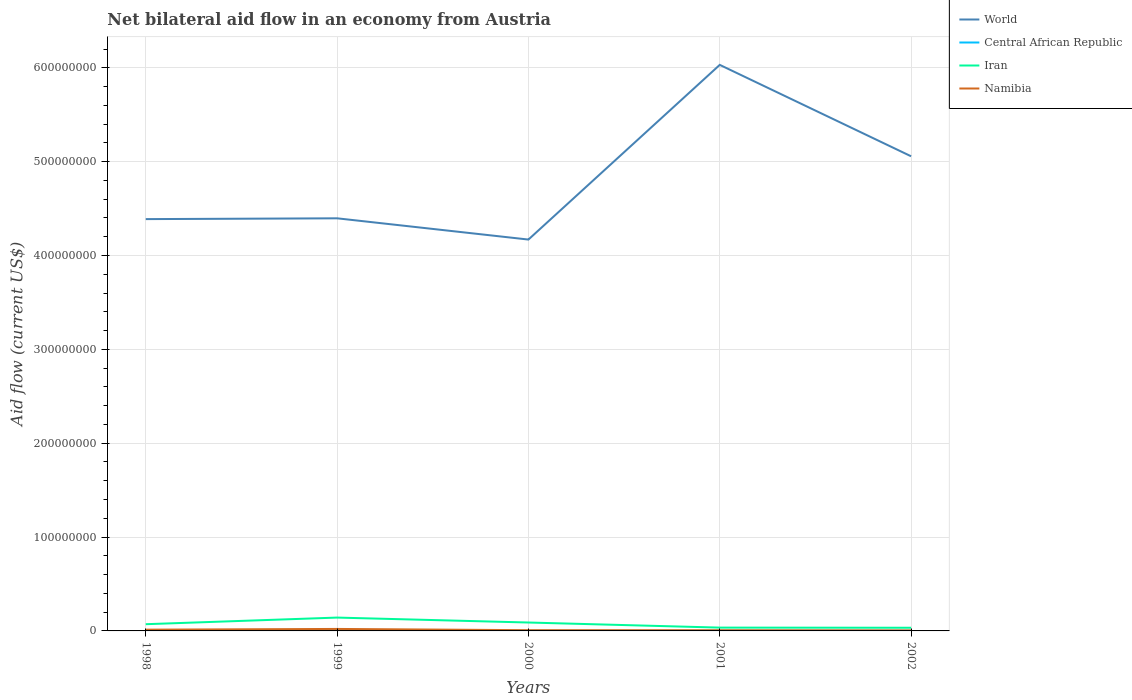Across all years, what is the maximum net bilateral aid flow in Central African Republic?
Offer a terse response. 1.40e+05. What is the total net bilateral aid flow in Namibia in the graph?
Your response must be concise. 5.50e+05. What is the difference between the highest and the second highest net bilateral aid flow in Iran?
Provide a short and direct response. 1.08e+07. What is the difference between the highest and the lowest net bilateral aid flow in Iran?
Ensure brevity in your answer.  2. How many years are there in the graph?
Your answer should be very brief. 5. What is the difference between two consecutive major ticks on the Y-axis?
Your answer should be very brief. 1.00e+08. How are the legend labels stacked?
Your response must be concise. Vertical. What is the title of the graph?
Keep it short and to the point. Net bilateral aid flow in an economy from Austria. What is the label or title of the X-axis?
Ensure brevity in your answer.  Years. What is the Aid flow (current US$) in World in 1998?
Provide a short and direct response. 4.39e+08. What is the Aid flow (current US$) in Central African Republic in 1998?
Offer a terse response. 5.50e+05. What is the Aid flow (current US$) of Iran in 1998?
Give a very brief answer. 7.16e+06. What is the Aid flow (current US$) in Namibia in 1998?
Provide a short and direct response. 1.33e+06. What is the Aid flow (current US$) in World in 1999?
Provide a short and direct response. 4.40e+08. What is the Aid flow (current US$) of Central African Republic in 1999?
Your answer should be compact. 7.40e+05. What is the Aid flow (current US$) of Iran in 1999?
Your response must be concise. 1.42e+07. What is the Aid flow (current US$) of Namibia in 1999?
Give a very brief answer. 2.11e+06. What is the Aid flow (current US$) of World in 2000?
Your answer should be very brief. 4.17e+08. What is the Aid flow (current US$) of Iran in 2000?
Your response must be concise. 8.95e+06. What is the Aid flow (current US$) of Namibia in 2000?
Offer a terse response. 7.80e+05. What is the Aid flow (current US$) in World in 2001?
Provide a succinct answer. 6.03e+08. What is the Aid flow (current US$) of Central African Republic in 2001?
Your answer should be compact. 2.00e+05. What is the Aid flow (current US$) in Iran in 2001?
Keep it short and to the point. 3.53e+06. What is the Aid flow (current US$) in Namibia in 2001?
Your response must be concise. 7.30e+05. What is the Aid flow (current US$) in World in 2002?
Offer a terse response. 5.06e+08. What is the Aid flow (current US$) of Iran in 2002?
Provide a short and direct response. 3.38e+06. What is the Aid flow (current US$) in Namibia in 2002?
Offer a terse response. 5.60e+05. Across all years, what is the maximum Aid flow (current US$) of World?
Your answer should be compact. 6.03e+08. Across all years, what is the maximum Aid flow (current US$) in Central African Republic?
Keep it short and to the point. 7.40e+05. Across all years, what is the maximum Aid flow (current US$) in Iran?
Provide a succinct answer. 1.42e+07. Across all years, what is the maximum Aid flow (current US$) of Namibia?
Keep it short and to the point. 2.11e+06. Across all years, what is the minimum Aid flow (current US$) of World?
Keep it short and to the point. 4.17e+08. Across all years, what is the minimum Aid flow (current US$) in Iran?
Provide a succinct answer. 3.38e+06. Across all years, what is the minimum Aid flow (current US$) in Namibia?
Offer a terse response. 5.60e+05. What is the total Aid flow (current US$) of World in the graph?
Your answer should be compact. 2.40e+09. What is the total Aid flow (current US$) of Central African Republic in the graph?
Keep it short and to the point. 1.79e+06. What is the total Aid flow (current US$) of Iran in the graph?
Your answer should be very brief. 3.72e+07. What is the total Aid flow (current US$) of Namibia in the graph?
Provide a short and direct response. 5.51e+06. What is the difference between the Aid flow (current US$) in World in 1998 and that in 1999?
Your answer should be compact. -8.60e+05. What is the difference between the Aid flow (current US$) of Iran in 1998 and that in 1999?
Provide a succinct answer. -7.06e+06. What is the difference between the Aid flow (current US$) in Namibia in 1998 and that in 1999?
Keep it short and to the point. -7.80e+05. What is the difference between the Aid flow (current US$) in World in 1998 and that in 2000?
Your answer should be compact. 2.18e+07. What is the difference between the Aid flow (current US$) of Iran in 1998 and that in 2000?
Your answer should be very brief. -1.79e+06. What is the difference between the Aid flow (current US$) of Namibia in 1998 and that in 2000?
Make the answer very short. 5.50e+05. What is the difference between the Aid flow (current US$) in World in 1998 and that in 2001?
Offer a terse response. -1.64e+08. What is the difference between the Aid flow (current US$) of Iran in 1998 and that in 2001?
Give a very brief answer. 3.63e+06. What is the difference between the Aid flow (current US$) of Namibia in 1998 and that in 2001?
Ensure brevity in your answer.  6.00e+05. What is the difference between the Aid flow (current US$) in World in 1998 and that in 2002?
Make the answer very short. -6.70e+07. What is the difference between the Aid flow (current US$) of Central African Republic in 1998 and that in 2002?
Your answer should be compact. 4.10e+05. What is the difference between the Aid flow (current US$) in Iran in 1998 and that in 2002?
Your answer should be compact. 3.78e+06. What is the difference between the Aid flow (current US$) in Namibia in 1998 and that in 2002?
Your response must be concise. 7.70e+05. What is the difference between the Aid flow (current US$) of World in 1999 and that in 2000?
Offer a very short reply. 2.26e+07. What is the difference between the Aid flow (current US$) of Central African Republic in 1999 and that in 2000?
Your answer should be compact. 5.80e+05. What is the difference between the Aid flow (current US$) of Iran in 1999 and that in 2000?
Make the answer very short. 5.27e+06. What is the difference between the Aid flow (current US$) in Namibia in 1999 and that in 2000?
Provide a succinct answer. 1.33e+06. What is the difference between the Aid flow (current US$) of World in 1999 and that in 2001?
Make the answer very short. -1.63e+08. What is the difference between the Aid flow (current US$) in Central African Republic in 1999 and that in 2001?
Keep it short and to the point. 5.40e+05. What is the difference between the Aid flow (current US$) in Iran in 1999 and that in 2001?
Provide a succinct answer. 1.07e+07. What is the difference between the Aid flow (current US$) in Namibia in 1999 and that in 2001?
Give a very brief answer. 1.38e+06. What is the difference between the Aid flow (current US$) of World in 1999 and that in 2002?
Your response must be concise. -6.61e+07. What is the difference between the Aid flow (current US$) of Central African Republic in 1999 and that in 2002?
Ensure brevity in your answer.  6.00e+05. What is the difference between the Aid flow (current US$) in Iran in 1999 and that in 2002?
Keep it short and to the point. 1.08e+07. What is the difference between the Aid flow (current US$) of Namibia in 1999 and that in 2002?
Offer a terse response. 1.55e+06. What is the difference between the Aid flow (current US$) of World in 2000 and that in 2001?
Your answer should be compact. -1.86e+08. What is the difference between the Aid flow (current US$) in Central African Republic in 2000 and that in 2001?
Offer a very short reply. -4.00e+04. What is the difference between the Aid flow (current US$) of Iran in 2000 and that in 2001?
Make the answer very short. 5.42e+06. What is the difference between the Aid flow (current US$) of World in 2000 and that in 2002?
Your answer should be compact. -8.87e+07. What is the difference between the Aid flow (current US$) in Central African Republic in 2000 and that in 2002?
Give a very brief answer. 2.00e+04. What is the difference between the Aid flow (current US$) of Iran in 2000 and that in 2002?
Offer a terse response. 5.57e+06. What is the difference between the Aid flow (current US$) in World in 2001 and that in 2002?
Make the answer very short. 9.74e+07. What is the difference between the Aid flow (current US$) in Central African Republic in 2001 and that in 2002?
Provide a short and direct response. 6.00e+04. What is the difference between the Aid flow (current US$) in Namibia in 2001 and that in 2002?
Provide a short and direct response. 1.70e+05. What is the difference between the Aid flow (current US$) in World in 1998 and the Aid flow (current US$) in Central African Republic in 1999?
Keep it short and to the point. 4.38e+08. What is the difference between the Aid flow (current US$) in World in 1998 and the Aid flow (current US$) in Iran in 1999?
Provide a succinct answer. 4.25e+08. What is the difference between the Aid flow (current US$) of World in 1998 and the Aid flow (current US$) of Namibia in 1999?
Offer a terse response. 4.37e+08. What is the difference between the Aid flow (current US$) in Central African Republic in 1998 and the Aid flow (current US$) in Iran in 1999?
Keep it short and to the point. -1.37e+07. What is the difference between the Aid flow (current US$) of Central African Republic in 1998 and the Aid flow (current US$) of Namibia in 1999?
Offer a terse response. -1.56e+06. What is the difference between the Aid flow (current US$) in Iran in 1998 and the Aid flow (current US$) in Namibia in 1999?
Provide a short and direct response. 5.05e+06. What is the difference between the Aid flow (current US$) of World in 1998 and the Aid flow (current US$) of Central African Republic in 2000?
Give a very brief answer. 4.39e+08. What is the difference between the Aid flow (current US$) in World in 1998 and the Aid flow (current US$) in Iran in 2000?
Ensure brevity in your answer.  4.30e+08. What is the difference between the Aid flow (current US$) of World in 1998 and the Aid flow (current US$) of Namibia in 2000?
Ensure brevity in your answer.  4.38e+08. What is the difference between the Aid flow (current US$) in Central African Republic in 1998 and the Aid flow (current US$) in Iran in 2000?
Provide a succinct answer. -8.40e+06. What is the difference between the Aid flow (current US$) of Iran in 1998 and the Aid flow (current US$) of Namibia in 2000?
Offer a very short reply. 6.38e+06. What is the difference between the Aid flow (current US$) of World in 1998 and the Aid flow (current US$) of Central African Republic in 2001?
Offer a terse response. 4.39e+08. What is the difference between the Aid flow (current US$) of World in 1998 and the Aid flow (current US$) of Iran in 2001?
Give a very brief answer. 4.35e+08. What is the difference between the Aid flow (current US$) in World in 1998 and the Aid flow (current US$) in Namibia in 2001?
Your answer should be very brief. 4.38e+08. What is the difference between the Aid flow (current US$) of Central African Republic in 1998 and the Aid flow (current US$) of Iran in 2001?
Your answer should be very brief. -2.98e+06. What is the difference between the Aid flow (current US$) of Iran in 1998 and the Aid flow (current US$) of Namibia in 2001?
Keep it short and to the point. 6.43e+06. What is the difference between the Aid flow (current US$) in World in 1998 and the Aid flow (current US$) in Central African Republic in 2002?
Ensure brevity in your answer.  4.39e+08. What is the difference between the Aid flow (current US$) of World in 1998 and the Aid flow (current US$) of Iran in 2002?
Offer a terse response. 4.35e+08. What is the difference between the Aid flow (current US$) of World in 1998 and the Aid flow (current US$) of Namibia in 2002?
Provide a succinct answer. 4.38e+08. What is the difference between the Aid flow (current US$) in Central African Republic in 1998 and the Aid flow (current US$) in Iran in 2002?
Provide a short and direct response. -2.83e+06. What is the difference between the Aid flow (current US$) in Iran in 1998 and the Aid flow (current US$) in Namibia in 2002?
Your answer should be compact. 6.60e+06. What is the difference between the Aid flow (current US$) of World in 1999 and the Aid flow (current US$) of Central African Republic in 2000?
Ensure brevity in your answer.  4.39e+08. What is the difference between the Aid flow (current US$) in World in 1999 and the Aid flow (current US$) in Iran in 2000?
Give a very brief answer. 4.31e+08. What is the difference between the Aid flow (current US$) in World in 1999 and the Aid flow (current US$) in Namibia in 2000?
Give a very brief answer. 4.39e+08. What is the difference between the Aid flow (current US$) in Central African Republic in 1999 and the Aid flow (current US$) in Iran in 2000?
Give a very brief answer. -8.21e+06. What is the difference between the Aid flow (current US$) in Iran in 1999 and the Aid flow (current US$) in Namibia in 2000?
Offer a terse response. 1.34e+07. What is the difference between the Aid flow (current US$) in World in 1999 and the Aid flow (current US$) in Central African Republic in 2001?
Provide a short and direct response. 4.39e+08. What is the difference between the Aid flow (current US$) of World in 1999 and the Aid flow (current US$) of Iran in 2001?
Your answer should be very brief. 4.36e+08. What is the difference between the Aid flow (current US$) in World in 1999 and the Aid flow (current US$) in Namibia in 2001?
Make the answer very short. 4.39e+08. What is the difference between the Aid flow (current US$) of Central African Republic in 1999 and the Aid flow (current US$) of Iran in 2001?
Your response must be concise. -2.79e+06. What is the difference between the Aid flow (current US$) in Iran in 1999 and the Aid flow (current US$) in Namibia in 2001?
Offer a terse response. 1.35e+07. What is the difference between the Aid flow (current US$) of World in 1999 and the Aid flow (current US$) of Central African Republic in 2002?
Your answer should be very brief. 4.40e+08. What is the difference between the Aid flow (current US$) in World in 1999 and the Aid flow (current US$) in Iran in 2002?
Keep it short and to the point. 4.36e+08. What is the difference between the Aid flow (current US$) of World in 1999 and the Aid flow (current US$) of Namibia in 2002?
Your answer should be compact. 4.39e+08. What is the difference between the Aid flow (current US$) of Central African Republic in 1999 and the Aid flow (current US$) of Iran in 2002?
Provide a short and direct response. -2.64e+06. What is the difference between the Aid flow (current US$) in Iran in 1999 and the Aid flow (current US$) in Namibia in 2002?
Your response must be concise. 1.37e+07. What is the difference between the Aid flow (current US$) in World in 2000 and the Aid flow (current US$) in Central African Republic in 2001?
Give a very brief answer. 4.17e+08. What is the difference between the Aid flow (current US$) of World in 2000 and the Aid flow (current US$) of Iran in 2001?
Keep it short and to the point. 4.13e+08. What is the difference between the Aid flow (current US$) in World in 2000 and the Aid flow (current US$) in Namibia in 2001?
Ensure brevity in your answer.  4.16e+08. What is the difference between the Aid flow (current US$) in Central African Republic in 2000 and the Aid flow (current US$) in Iran in 2001?
Give a very brief answer. -3.37e+06. What is the difference between the Aid flow (current US$) of Central African Republic in 2000 and the Aid flow (current US$) of Namibia in 2001?
Offer a terse response. -5.70e+05. What is the difference between the Aid flow (current US$) of Iran in 2000 and the Aid flow (current US$) of Namibia in 2001?
Your answer should be compact. 8.22e+06. What is the difference between the Aid flow (current US$) in World in 2000 and the Aid flow (current US$) in Central African Republic in 2002?
Offer a terse response. 4.17e+08. What is the difference between the Aid flow (current US$) of World in 2000 and the Aid flow (current US$) of Iran in 2002?
Your answer should be very brief. 4.14e+08. What is the difference between the Aid flow (current US$) in World in 2000 and the Aid flow (current US$) in Namibia in 2002?
Keep it short and to the point. 4.16e+08. What is the difference between the Aid flow (current US$) in Central African Republic in 2000 and the Aid flow (current US$) in Iran in 2002?
Provide a succinct answer. -3.22e+06. What is the difference between the Aid flow (current US$) in Central African Republic in 2000 and the Aid flow (current US$) in Namibia in 2002?
Provide a short and direct response. -4.00e+05. What is the difference between the Aid flow (current US$) of Iran in 2000 and the Aid flow (current US$) of Namibia in 2002?
Keep it short and to the point. 8.39e+06. What is the difference between the Aid flow (current US$) in World in 2001 and the Aid flow (current US$) in Central African Republic in 2002?
Keep it short and to the point. 6.03e+08. What is the difference between the Aid flow (current US$) in World in 2001 and the Aid flow (current US$) in Iran in 2002?
Offer a very short reply. 6.00e+08. What is the difference between the Aid flow (current US$) in World in 2001 and the Aid flow (current US$) in Namibia in 2002?
Offer a very short reply. 6.03e+08. What is the difference between the Aid flow (current US$) in Central African Republic in 2001 and the Aid flow (current US$) in Iran in 2002?
Offer a very short reply. -3.18e+06. What is the difference between the Aid flow (current US$) in Central African Republic in 2001 and the Aid flow (current US$) in Namibia in 2002?
Provide a succinct answer. -3.60e+05. What is the difference between the Aid flow (current US$) of Iran in 2001 and the Aid flow (current US$) of Namibia in 2002?
Offer a very short reply. 2.97e+06. What is the average Aid flow (current US$) in World per year?
Your answer should be compact. 4.81e+08. What is the average Aid flow (current US$) of Central African Republic per year?
Make the answer very short. 3.58e+05. What is the average Aid flow (current US$) in Iran per year?
Offer a terse response. 7.45e+06. What is the average Aid flow (current US$) in Namibia per year?
Your answer should be compact. 1.10e+06. In the year 1998, what is the difference between the Aid flow (current US$) in World and Aid flow (current US$) in Central African Republic?
Give a very brief answer. 4.38e+08. In the year 1998, what is the difference between the Aid flow (current US$) of World and Aid flow (current US$) of Iran?
Your answer should be compact. 4.32e+08. In the year 1998, what is the difference between the Aid flow (current US$) of World and Aid flow (current US$) of Namibia?
Offer a very short reply. 4.37e+08. In the year 1998, what is the difference between the Aid flow (current US$) of Central African Republic and Aid flow (current US$) of Iran?
Offer a terse response. -6.61e+06. In the year 1998, what is the difference between the Aid flow (current US$) of Central African Republic and Aid flow (current US$) of Namibia?
Give a very brief answer. -7.80e+05. In the year 1998, what is the difference between the Aid flow (current US$) of Iran and Aid flow (current US$) of Namibia?
Offer a very short reply. 5.83e+06. In the year 1999, what is the difference between the Aid flow (current US$) of World and Aid flow (current US$) of Central African Republic?
Offer a terse response. 4.39e+08. In the year 1999, what is the difference between the Aid flow (current US$) of World and Aid flow (current US$) of Iran?
Give a very brief answer. 4.25e+08. In the year 1999, what is the difference between the Aid flow (current US$) in World and Aid flow (current US$) in Namibia?
Offer a terse response. 4.38e+08. In the year 1999, what is the difference between the Aid flow (current US$) in Central African Republic and Aid flow (current US$) in Iran?
Offer a terse response. -1.35e+07. In the year 1999, what is the difference between the Aid flow (current US$) of Central African Republic and Aid flow (current US$) of Namibia?
Your response must be concise. -1.37e+06. In the year 1999, what is the difference between the Aid flow (current US$) in Iran and Aid flow (current US$) in Namibia?
Provide a succinct answer. 1.21e+07. In the year 2000, what is the difference between the Aid flow (current US$) in World and Aid flow (current US$) in Central African Republic?
Your answer should be compact. 4.17e+08. In the year 2000, what is the difference between the Aid flow (current US$) in World and Aid flow (current US$) in Iran?
Your answer should be very brief. 4.08e+08. In the year 2000, what is the difference between the Aid flow (current US$) in World and Aid flow (current US$) in Namibia?
Provide a short and direct response. 4.16e+08. In the year 2000, what is the difference between the Aid flow (current US$) of Central African Republic and Aid flow (current US$) of Iran?
Make the answer very short. -8.79e+06. In the year 2000, what is the difference between the Aid flow (current US$) in Central African Republic and Aid flow (current US$) in Namibia?
Provide a short and direct response. -6.20e+05. In the year 2000, what is the difference between the Aid flow (current US$) in Iran and Aid flow (current US$) in Namibia?
Provide a short and direct response. 8.17e+06. In the year 2001, what is the difference between the Aid flow (current US$) in World and Aid flow (current US$) in Central African Republic?
Your answer should be compact. 6.03e+08. In the year 2001, what is the difference between the Aid flow (current US$) of World and Aid flow (current US$) of Iran?
Make the answer very short. 6.00e+08. In the year 2001, what is the difference between the Aid flow (current US$) in World and Aid flow (current US$) in Namibia?
Provide a short and direct response. 6.02e+08. In the year 2001, what is the difference between the Aid flow (current US$) in Central African Republic and Aid flow (current US$) in Iran?
Ensure brevity in your answer.  -3.33e+06. In the year 2001, what is the difference between the Aid flow (current US$) of Central African Republic and Aid flow (current US$) of Namibia?
Your answer should be compact. -5.30e+05. In the year 2001, what is the difference between the Aid flow (current US$) in Iran and Aid flow (current US$) in Namibia?
Give a very brief answer. 2.80e+06. In the year 2002, what is the difference between the Aid flow (current US$) in World and Aid flow (current US$) in Central African Republic?
Keep it short and to the point. 5.06e+08. In the year 2002, what is the difference between the Aid flow (current US$) of World and Aid flow (current US$) of Iran?
Offer a very short reply. 5.02e+08. In the year 2002, what is the difference between the Aid flow (current US$) in World and Aid flow (current US$) in Namibia?
Your answer should be compact. 5.05e+08. In the year 2002, what is the difference between the Aid flow (current US$) in Central African Republic and Aid flow (current US$) in Iran?
Keep it short and to the point. -3.24e+06. In the year 2002, what is the difference between the Aid flow (current US$) of Central African Republic and Aid flow (current US$) of Namibia?
Give a very brief answer. -4.20e+05. In the year 2002, what is the difference between the Aid flow (current US$) in Iran and Aid flow (current US$) in Namibia?
Provide a short and direct response. 2.82e+06. What is the ratio of the Aid flow (current US$) of Central African Republic in 1998 to that in 1999?
Offer a terse response. 0.74. What is the ratio of the Aid flow (current US$) of Iran in 1998 to that in 1999?
Offer a very short reply. 0.5. What is the ratio of the Aid flow (current US$) in Namibia in 1998 to that in 1999?
Your answer should be very brief. 0.63. What is the ratio of the Aid flow (current US$) of World in 1998 to that in 2000?
Your answer should be very brief. 1.05. What is the ratio of the Aid flow (current US$) in Central African Republic in 1998 to that in 2000?
Provide a succinct answer. 3.44. What is the ratio of the Aid flow (current US$) of Iran in 1998 to that in 2000?
Keep it short and to the point. 0.8. What is the ratio of the Aid flow (current US$) of Namibia in 1998 to that in 2000?
Keep it short and to the point. 1.71. What is the ratio of the Aid flow (current US$) of World in 1998 to that in 2001?
Ensure brevity in your answer.  0.73. What is the ratio of the Aid flow (current US$) in Central African Republic in 1998 to that in 2001?
Keep it short and to the point. 2.75. What is the ratio of the Aid flow (current US$) of Iran in 1998 to that in 2001?
Ensure brevity in your answer.  2.03. What is the ratio of the Aid flow (current US$) of Namibia in 1998 to that in 2001?
Your response must be concise. 1.82. What is the ratio of the Aid flow (current US$) of World in 1998 to that in 2002?
Offer a very short reply. 0.87. What is the ratio of the Aid flow (current US$) of Central African Republic in 1998 to that in 2002?
Provide a succinct answer. 3.93. What is the ratio of the Aid flow (current US$) in Iran in 1998 to that in 2002?
Offer a terse response. 2.12. What is the ratio of the Aid flow (current US$) in Namibia in 1998 to that in 2002?
Provide a succinct answer. 2.38. What is the ratio of the Aid flow (current US$) of World in 1999 to that in 2000?
Offer a terse response. 1.05. What is the ratio of the Aid flow (current US$) in Central African Republic in 1999 to that in 2000?
Your answer should be compact. 4.62. What is the ratio of the Aid flow (current US$) of Iran in 1999 to that in 2000?
Provide a short and direct response. 1.59. What is the ratio of the Aid flow (current US$) of Namibia in 1999 to that in 2000?
Provide a short and direct response. 2.71. What is the ratio of the Aid flow (current US$) of World in 1999 to that in 2001?
Make the answer very short. 0.73. What is the ratio of the Aid flow (current US$) in Iran in 1999 to that in 2001?
Your answer should be compact. 4.03. What is the ratio of the Aid flow (current US$) in Namibia in 1999 to that in 2001?
Keep it short and to the point. 2.89. What is the ratio of the Aid flow (current US$) in World in 1999 to that in 2002?
Your answer should be compact. 0.87. What is the ratio of the Aid flow (current US$) of Central African Republic in 1999 to that in 2002?
Offer a very short reply. 5.29. What is the ratio of the Aid flow (current US$) in Iran in 1999 to that in 2002?
Keep it short and to the point. 4.21. What is the ratio of the Aid flow (current US$) in Namibia in 1999 to that in 2002?
Provide a short and direct response. 3.77. What is the ratio of the Aid flow (current US$) of World in 2000 to that in 2001?
Offer a terse response. 0.69. What is the ratio of the Aid flow (current US$) of Iran in 2000 to that in 2001?
Make the answer very short. 2.54. What is the ratio of the Aid flow (current US$) in Namibia in 2000 to that in 2001?
Your answer should be very brief. 1.07. What is the ratio of the Aid flow (current US$) of World in 2000 to that in 2002?
Keep it short and to the point. 0.82. What is the ratio of the Aid flow (current US$) of Central African Republic in 2000 to that in 2002?
Your answer should be very brief. 1.14. What is the ratio of the Aid flow (current US$) of Iran in 2000 to that in 2002?
Make the answer very short. 2.65. What is the ratio of the Aid flow (current US$) of Namibia in 2000 to that in 2002?
Offer a very short reply. 1.39. What is the ratio of the Aid flow (current US$) in World in 2001 to that in 2002?
Offer a terse response. 1.19. What is the ratio of the Aid flow (current US$) in Central African Republic in 2001 to that in 2002?
Keep it short and to the point. 1.43. What is the ratio of the Aid flow (current US$) of Iran in 2001 to that in 2002?
Give a very brief answer. 1.04. What is the ratio of the Aid flow (current US$) of Namibia in 2001 to that in 2002?
Your response must be concise. 1.3. What is the difference between the highest and the second highest Aid flow (current US$) of World?
Offer a terse response. 9.74e+07. What is the difference between the highest and the second highest Aid flow (current US$) of Central African Republic?
Your response must be concise. 1.90e+05. What is the difference between the highest and the second highest Aid flow (current US$) of Iran?
Your answer should be compact. 5.27e+06. What is the difference between the highest and the second highest Aid flow (current US$) in Namibia?
Offer a very short reply. 7.80e+05. What is the difference between the highest and the lowest Aid flow (current US$) of World?
Your answer should be very brief. 1.86e+08. What is the difference between the highest and the lowest Aid flow (current US$) of Central African Republic?
Make the answer very short. 6.00e+05. What is the difference between the highest and the lowest Aid flow (current US$) of Iran?
Your response must be concise. 1.08e+07. What is the difference between the highest and the lowest Aid flow (current US$) of Namibia?
Give a very brief answer. 1.55e+06. 